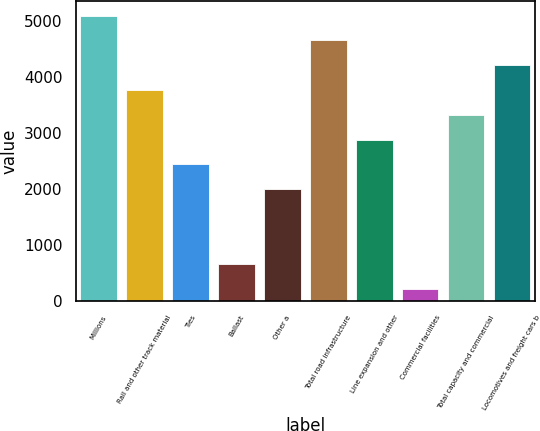Convert chart to OTSL. <chart><loc_0><loc_0><loc_500><loc_500><bar_chart><fcel>Millions<fcel>Rail and other track material<fcel>Ties<fcel>Ballast<fcel>Other a<fcel>Total road infrastructure<fcel>Line expansion and other<fcel>Commercial facilities<fcel>Total capacity and commercial<fcel>Locomotives and freight cars b<nl><fcel>5092.3<fcel>3765.4<fcel>2438.5<fcel>669.3<fcel>1996.2<fcel>4650<fcel>2880.8<fcel>227<fcel>3323.1<fcel>4207.7<nl></chart> 